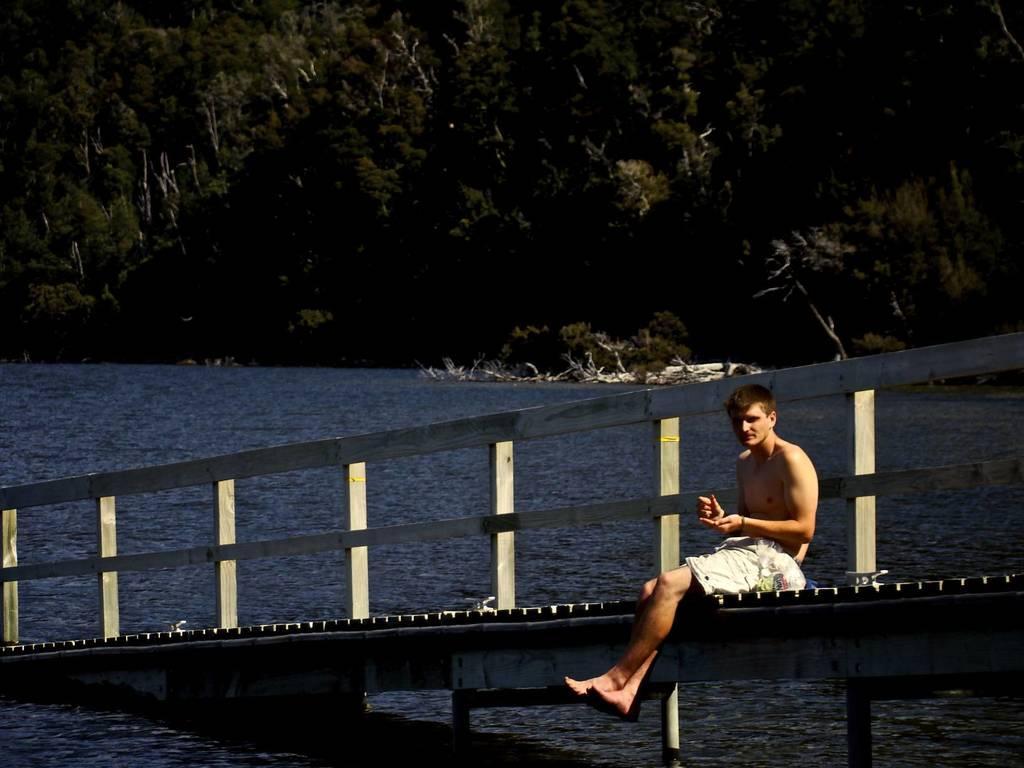How would you summarize this image in a sentence or two? In this image there is a boy sitting on the bridge without the shirt. Under the bridge there is water. In the background there are trees. 